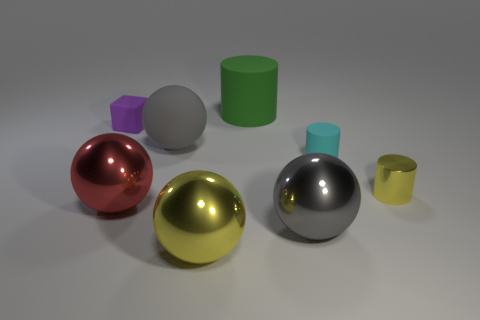There is a object behind the block; what is its color?
Provide a short and direct response. Green. What is the material of the big thing that is the same color as the matte sphere?
Give a very brief answer. Metal. Is there a small rubber object of the same shape as the big green rubber object?
Give a very brief answer. Yes. How many small cyan things are the same shape as the green object?
Keep it short and to the point. 1. Is the small shiny thing the same color as the matte ball?
Provide a succinct answer. No. Are there fewer small gray spheres than big green matte cylinders?
Offer a terse response. Yes. What is the material of the large gray ball to the left of the big yellow metal ball?
Ensure brevity in your answer.  Rubber. There is a purple block that is the same size as the cyan cylinder; what is its material?
Keep it short and to the point. Rubber. There is a purple thing left of the yellow object that is on the left side of the cylinder behind the purple rubber block; what is it made of?
Your response must be concise. Rubber. Is the size of the matte object behind the purple rubber block the same as the large red thing?
Your response must be concise. Yes. 